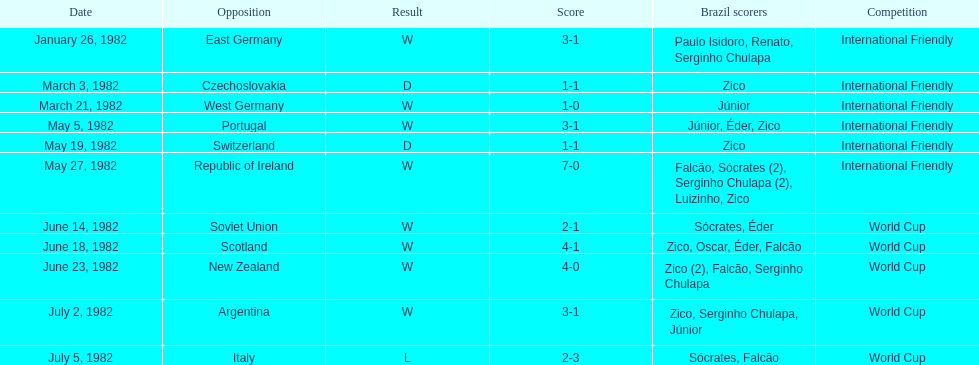Which team did brazil score more goals against in 1982: the soviet union or portugal? Portugal. 